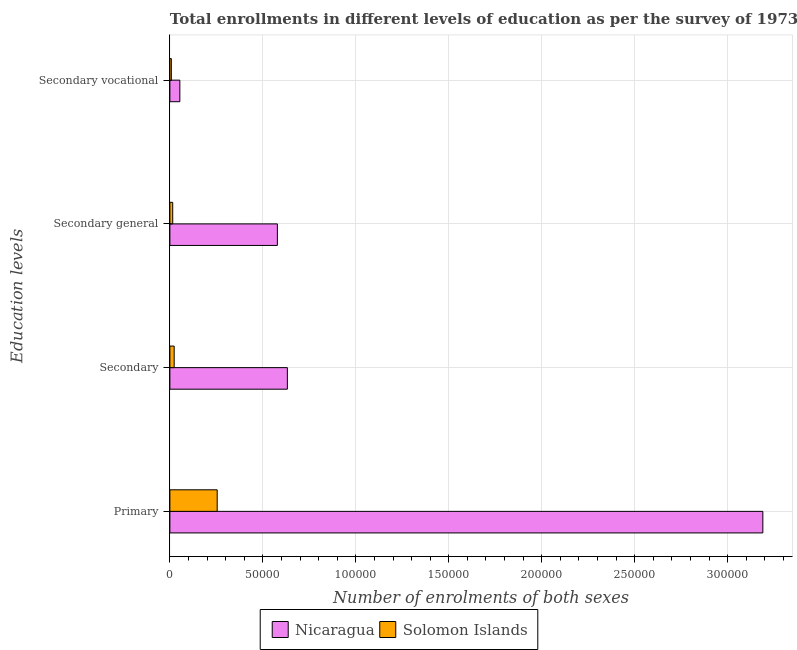How many groups of bars are there?
Your response must be concise. 4. Are the number of bars on each tick of the Y-axis equal?
Your response must be concise. Yes. How many bars are there on the 4th tick from the top?
Ensure brevity in your answer.  2. How many bars are there on the 2nd tick from the bottom?
Your answer should be very brief. 2. What is the label of the 2nd group of bars from the top?
Your answer should be very brief. Secondary general. What is the number of enrolments in secondary general education in Solomon Islands?
Keep it short and to the point. 1526. Across all countries, what is the maximum number of enrolments in secondary education?
Ensure brevity in your answer.  6.32e+04. Across all countries, what is the minimum number of enrolments in secondary vocational education?
Provide a short and direct response. 784. In which country was the number of enrolments in secondary general education maximum?
Offer a terse response. Nicaragua. In which country was the number of enrolments in primary education minimum?
Ensure brevity in your answer.  Solomon Islands. What is the total number of enrolments in secondary vocational education in the graph?
Provide a succinct answer. 6147. What is the difference between the number of enrolments in primary education in Solomon Islands and that in Nicaragua?
Provide a succinct answer. -2.93e+05. What is the difference between the number of enrolments in secondary education in Solomon Islands and the number of enrolments in primary education in Nicaragua?
Provide a succinct answer. -3.17e+05. What is the average number of enrolments in primary education per country?
Your answer should be compact. 1.72e+05. What is the difference between the number of enrolments in primary education and number of enrolments in secondary general education in Nicaragua?
Your answer should be compact. 2.61e+05. In how many countries, is the number of enrolments in secondary general education greater than 80000 ?
Offer a very short reply. 0. What is the ratio of the number of enrolments in secondary general education in Solomon Islands to that in Nicaragua?
Make the answer very short. 0.03. Is the number of enrolments in primary education in Solomon Islands less than that in Nicaragua?
Offer a very short reply. Yes. What is the difference between the highest and the second highest number of enrolments in primary education?
Your answer should be very brief. 2.93e+05. What is the difference between the highest and the lowest number of enrolments in secondary vocational education?
Your response must be concise. 4579. In how many countries, is the number of enrolments in secondary vocational education greater than the average number of enrolments in secondary vocational education taken over all countries?
Your answer should be very brief. 1. Is the sum of the number of enrolments in secondary vocational education in Nicaragua and Solomon Islands greater than the maximum number of enrolments in secondary education across all countries?
Offer a terse response. No. What does the 2nd bar from the top in Secondary general represents?
Your answer should be very brief. Nicaragua. What does the 2nd bar from the bottom in Primary represents?
Keep it short and to the point. Solomon Islands. Are all the bars in the graph horizontal?
Make the answer very short. Yes. How many countries are there in the graph?
Make the answer very short. 2. What is the difference between two consecutive major ticks on the X-axis?
Your answer should be very brief. 5.00e+04. Does the graph contain any zero values?
Keep it short and to the point. No. Does the graph contain grids?
Keep it short and to the point. Yes. Where does the legend appear in the graph?
Your answer should be compact. Bottom center. What is the title of the graph?
Keep it short and to the point. Total enrollments in different levels of education as per the survey of 1973. What is the label or title of the X-axis?
Make the answer very short. Number of enrolments of both sexes. What is the label or title of the Y-axis?
Offer a terse response. Education levels. What is the Number of enrolments of both sexes of Nicaragua in Primary?
Ensure brevity in your answer.  3.19e+05. What is the Number of enrolments of both sexes of Solomon Islands in Primary?
Your answer should be compact. 2.54e+04. What is the Number of enrolments of both sexes in Nicaragua in Secondary?
Provide a succinct answer. 6.32e+04. What is the Number of enrolments of both sexes in Solomon Islands in Secondary?
Provide a short and direct response. 2310. What is the Number of enrolments of both sexes in Nicaragua in Secondary general?
Ensure brevity in your answer.  5.78e+04. What is the Number of enrolments of both sexes of Solomon Islands in Secondary general?
Your answer should be very brief. 1526. What is the Number of enrolments of both sexes of Nicaragua in Secondary vocational?
Offer a very short reply. 5363. What is the Number of enrolments of both sexes of Solomon Islands in Secondary vocational?
Your response must be concise. 784. Across all Education levels, what is the maximum Number of enrolments of both sexes of Nicaragua?
Offer a very short reply. 3.19e+05. Across all Education levels, what is the maximum Number of enrolments of both sexes of Solomon Islands?
Provide a short and direct response. 2.54e+04. Across all Education levels, what is the minimum Number of enrolments of both sexes of Nicaragua?
Keep it short and to the point. 5363. Across all Education levels, what is the minimum Number of enrolments of both sexes of Solomon Islands?
Offer a very short reply. 784. What is the total Number of enrolments of both sexes of Nicaragua in the graph?
Ensure brevity in your answer.  4.45e+05. What is the total Number of enrolments of both sexes of Solomon Islands in the graph?
Provide a short and direct response. 3.01e+04. What is the difference between the Number of enrolments of both sexes in Nicaragua in Primary and that in Secondary?
Offer a terse response. 2.56e+05. What is the difference between the Number of enrolments of both sexes of Solomon Islands in Primary and that in Secondary?
Keep it short and to the point. 2.31e+04. What is the difference between the Number of enrolments of both sexes of Nicaragua in Primary and that in Secondary general?
Your answer should be very brief. 2.61e+05. What is the difference between the Number of enrolments of both sexes in Solomon Islands in Primary and that in Secondary general?
Keep it short and to the point. 2.39e+04. What is the difference between the Number of enrolments of both sexes of Nicaragua in Primary and that in Secondary vocational?
Your answer should be very brief. 3.14e+05. What is the difference between the Number of enrolments of both sexes of Solomon Islands in Primary and that in Secondary vocational?
Offer a terse response. 2.47e+04. What is the difference between the Number of enrolments of both sexes of Nicaragua in Secondary and that in Secondary general?
Make the answer very short. 5363. What is the difference between the Number of enrolments of both sexes of Solomon Islands in Secondary and that in Secondary general?
Offer a terse response. 784. What is the difference between the Number of enrolments of both sexes of Nicaragua in Secondary and that in Secondary vocational?
Ensure brevity in your answer.  5.78e+04. What is the difference between the Number of enrolments of both sexes of Solomon Islands in Secondary and that in Secondary vocational?
Your answer should be very brief. 1526. What is the difference between the Number of enrolments of both sexes in Nicaragua in Secondary general and that in Secondary vocational?
Your answer should be compact. 5.25e+04. What is the difference between the Number of enrolments of both sexes in Solomon Islands in Secondary general and that in Secondary vocational?
Provide a succinct answer. 742. What is the difference between the Number of enrolments of both sexes of Nicaragua in Primary and the Number of enrolments of both sexes of Solomon Islands in Secondary?
Give a very brief answer. 3.17e+05. What is the difference between the Number of enrolments of both sexes in Nicaragua in Primary and the Number of enrolments of both sexes in Solomon Islands in Secondary general?
Keep it short and to the point. 3.17e+05. What is the difference between the Number of enrolments of both sexes of Nicaragua in Primary and the Number of enrolments of both sexes of Solomon Islands in Secondary vocational?
Make the answer very short. 3.18e+05. What is the difference between the Number of enrolments of both sexes in Nicaragua in Secondary and the Number of enrolments of both sexes in Solomon Islands in Secondary general?
Offer a terse response. 6.17e+04. What is the difference between the Number of enrolments of both sexes in Nicaragua in Secondary and the Number of enrolments of both sexes in Solomon Islands in Secondary vocational?
Your answer should be compact. 6.24e+04. What is the difference between the Number of enrolments of both sexes of Nicaragua in Secondary general and the Number of enrolments of both sexes of Solomon Islands in Secondary vocational?
Offer a very short reply. 5.70e+04. What is the average Number of enrolments of both sexes in Nicaragua per Education levels?
Offer a very short reply. 1.11e+05. What is the average Number of enrolments of both sexes of Solomon Islands per Education levels?
Provide a succinct answer. 7515.5. What is the difference between the Number of enrolments of both sexes of Nicaragua and Number of enrolments of both sexes of Solomon Islands in Primary?
Provide a short and direct response. 2.93e+05. What is the difference between the Number of enrolments of both sexes in Nicaragua and Number of enrolments of both sexes in Solomon Islands in Secondary?
Provide a short and direct response. 6.09e+04. What is the difference between the Number of enrolments of both sexes in Nicaragua and Number of enrolments of both sexes in Solomon Islands in Secondary general?
Provide a succinct answer. 5.63e+04. What is the difference between the Number of enrolments of both sexes of Nicaragua and Number of enrolments of both sexes of Solomon Islands in Secondary vocational?
Offer a very short reply. 4579. What is the ratio of the Number of enrolments of both sexes in Nicaragua in Primary to that in Secondary?
Ensure brevity in your answer.  5.05. What is the ratio of the Number of enrolments of both sexes of Solomon Islands in Primary to that in Secondary?
Your response must be concise. 11.01. What is the ratio of the Number of enrolments of both sexes in Nicaragua in Primary to that in Secondary general?
Offer a terse response. 5.52. What is the ratio of the Number of enrolments of both sexes of Solomon Islands in Primary to that in Secondary general?
Give a very brief answer. 16.67. What is the ratio of the Number of enrolments of both sexes of Nicaragua in Primary to that in Secondary vocational?
Offer a terse response. 59.46. What is the ratio of the Number of enrolments of both sexes of Solomon Islands in Primary to that in Secondary vocational?
Make the answer very short. 32.45. What is the ratio of the Number of enrolments of both sexes of Nicaragua in Secondary to that in Secondary general?
Your answer should be very brief. 1.09. What is the ratio of the Number of enrolments of both sexes in Solomon Islands in Secondary to that in Secondary general?
Ensure brevity in your answer.  1.51. What is the ratio of the Number of enrolments of both sexes in Nicaragua in Secondary to that in Secondary vocational?
Your response must be concise. 11.78. What is the ratio of the Number of enrolments of both sexes in Solomon Islands in Secondary to that in Secondary vocational?
Your response must be concise. 2.95. What is the ratio of the Number of enrolments of both sexes of Nicaragua in Secondary general to that in Secondary vocational?
Offer a very short reply. 10.78. What is the ratio of the Number of enrolments of both sexes of Solomon Islands in Secondary general to that in Secondary vocational?
Your answer should be very brief. 1.95. What is the difference between the highest and the second highest Number of enrolments of both sexes in Nicaragua?
Make the answer very short. 2.56e+05. What is the difference between the highest and the second highest Number of enrolments of both sexes of Solomon Islands?
Keep it short and to the point. 2.31e+04. What is the difference between the highest and the lowest Number of enrolments of both sexes in Nicaragua?
Your answer should be compact. 3.14e+05. What is the difference between the highest and the lowest Number of enrolments of both sexes of Solomon Islands?
Provide a short and direct response. 2.47e+04. 